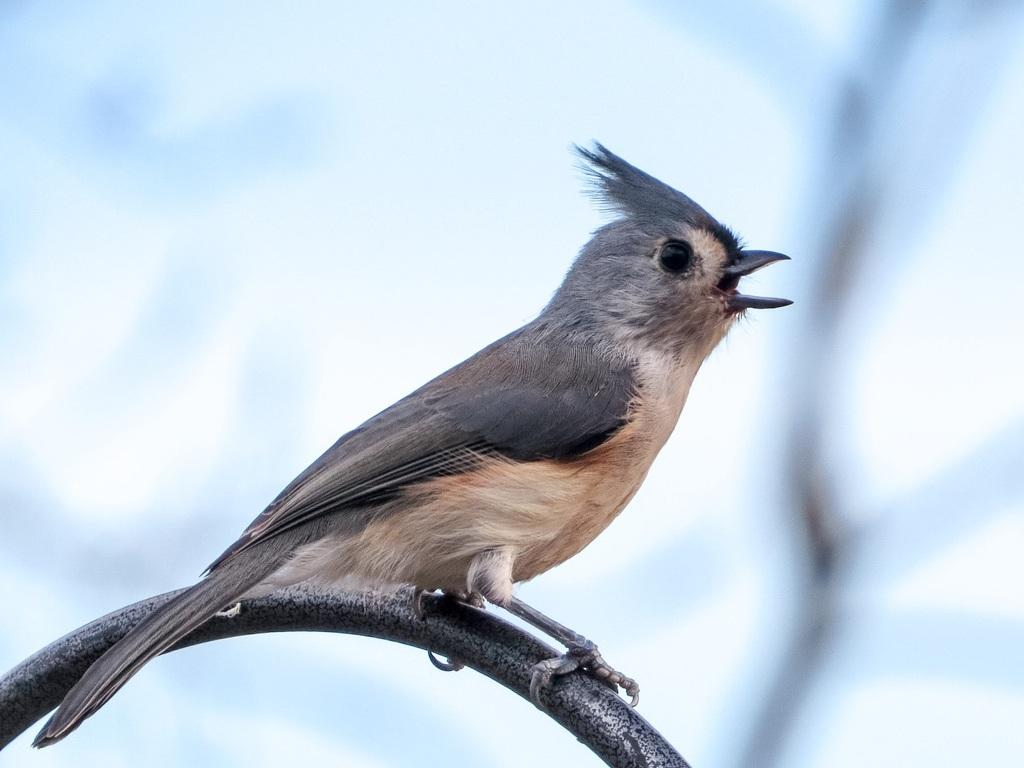What type of animal is in the image? There is a bird in the image. Where is the bird located? The bird is on a metal rod. What can be seen in the background of the image? There is sky visible in the background of the image. Can you see a toad sitting on the dock in the image? There is no toad or dock present in the image; it features a bird on a metal rod with sky visible in the background. 